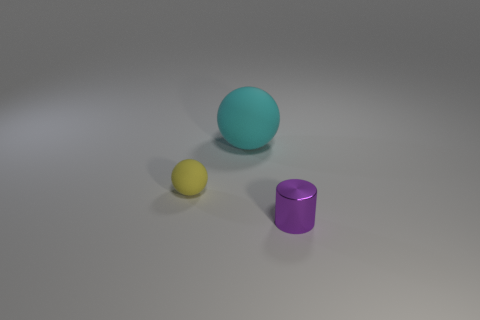What is the shape of the small purple thing?
Make the answer very short. Cylinder. How many other matte spheres are the same color as the tiny matte ball?
Give a very brief answer. 0. What is the shape of the yellow thing that is the same size as the purple cylinder?
Your response must be concise. Sphere. Are there any cyan balls of the same size as the yellow object?
Offer a very short reply. No. What is the material of the yellow sphere that is the same size as the shiny thing?
Ensure brevity in your answer.  Rubber. There is a matte sphere left of the matte ball that is to the right of the yellow matte sphere; what size is it?
Provide a short and direct response. Small. Does the matte sphere on the left side of the cyan matte object have the same size as the purple thing?
Make the answer very short. Yes. Are there more rubber things behind the large rubber thing than small things to the left of the small purple metal cylinder?
Offer a very short reply. No. There is a thing that is behind the cylinder and to the right of the tiny yellow thing; what is its shape?
Keep it short and to the point. Sphere. There is a thing in front of the tiny yellow matte object; what is its shape?
Your response must be concise. Cylinder. 